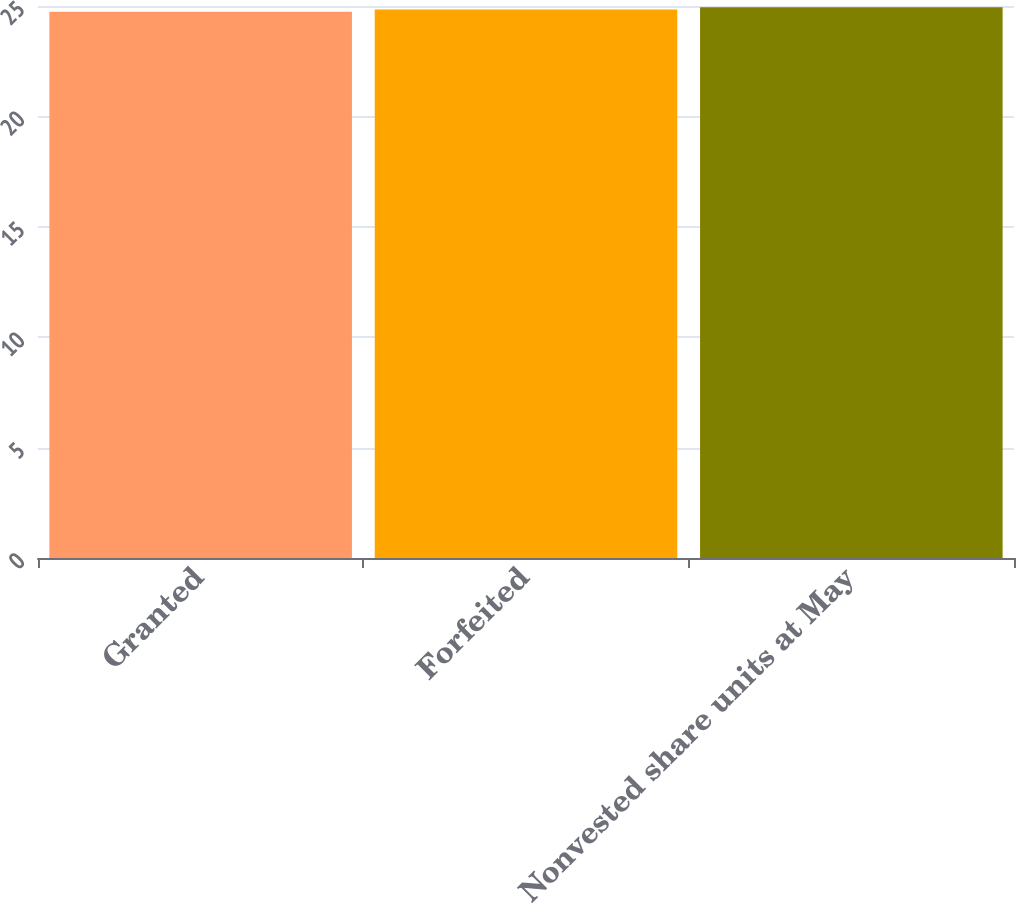Convert chart. <chart><loc_0><loc_0><loc_500><loc_500><bar_chart><fcel>Granted<fcel>Forfeited<fcel>Nonvested share units at May<nl><fcel>24.74<fcel>24.84<fcel>24.94<nl></chart> 